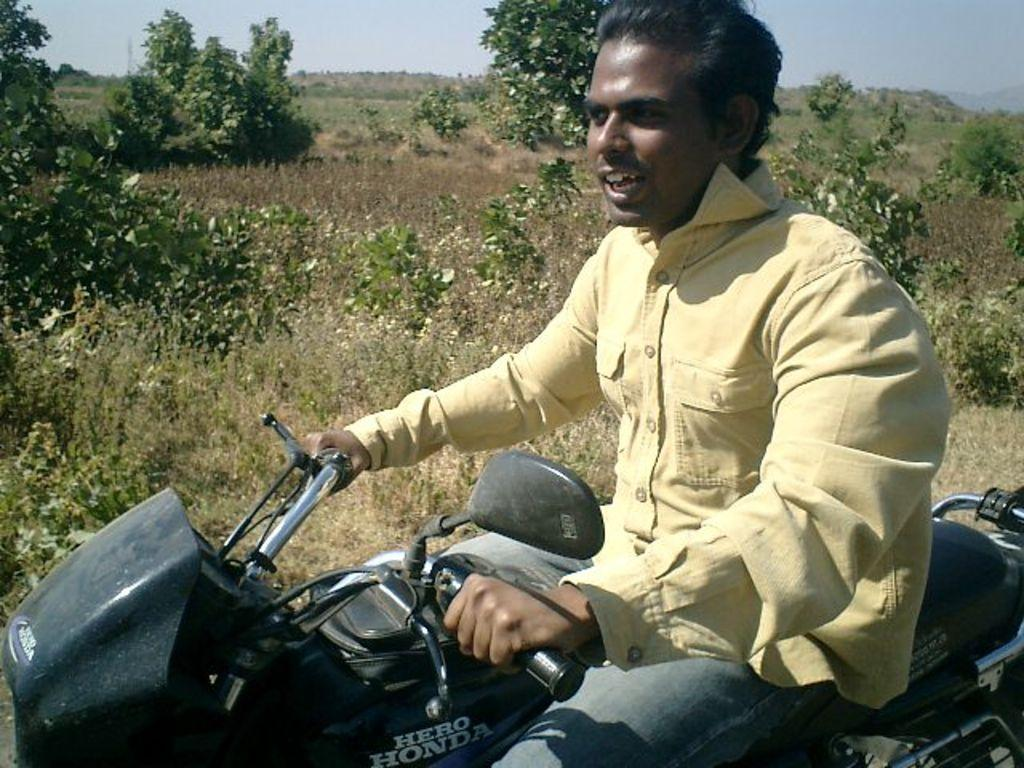Who is the main subject in the image? There is a man in the image. What is the man doing in the image? The man is riding a motorbike. What can be seen in the background of the image? There are trees visible in the image. How many women are flying kites in the image? There are no women or kites present in the image. What is the value of a cent in the image? There is no reference to currency or value in the image. 